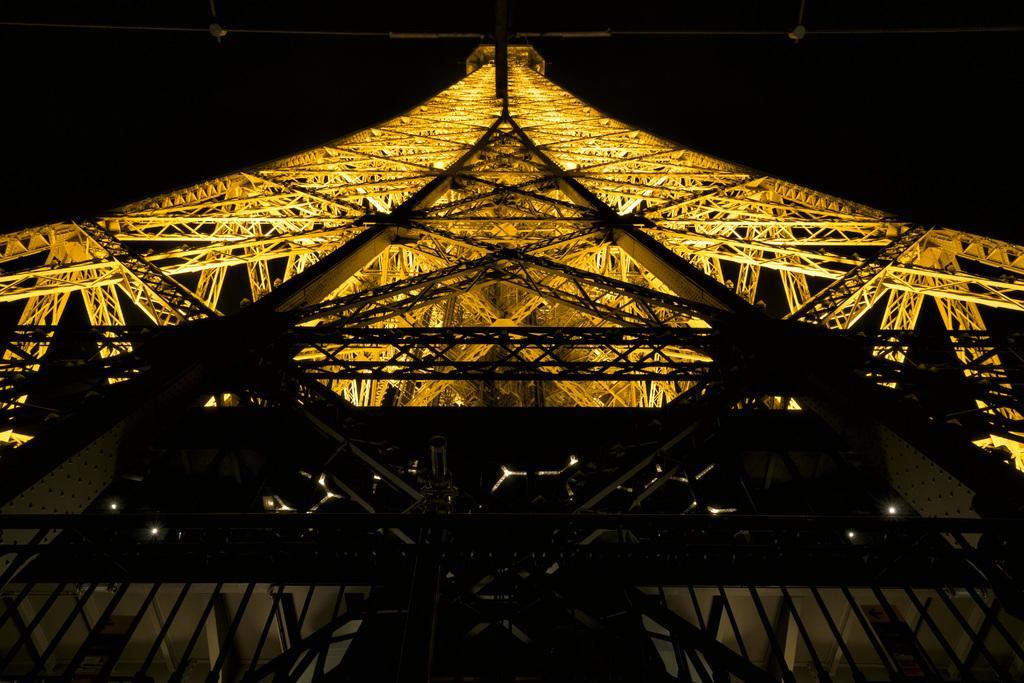How would you summarize this image in a sentence or two? In this image we can see a tower and there are lights. 